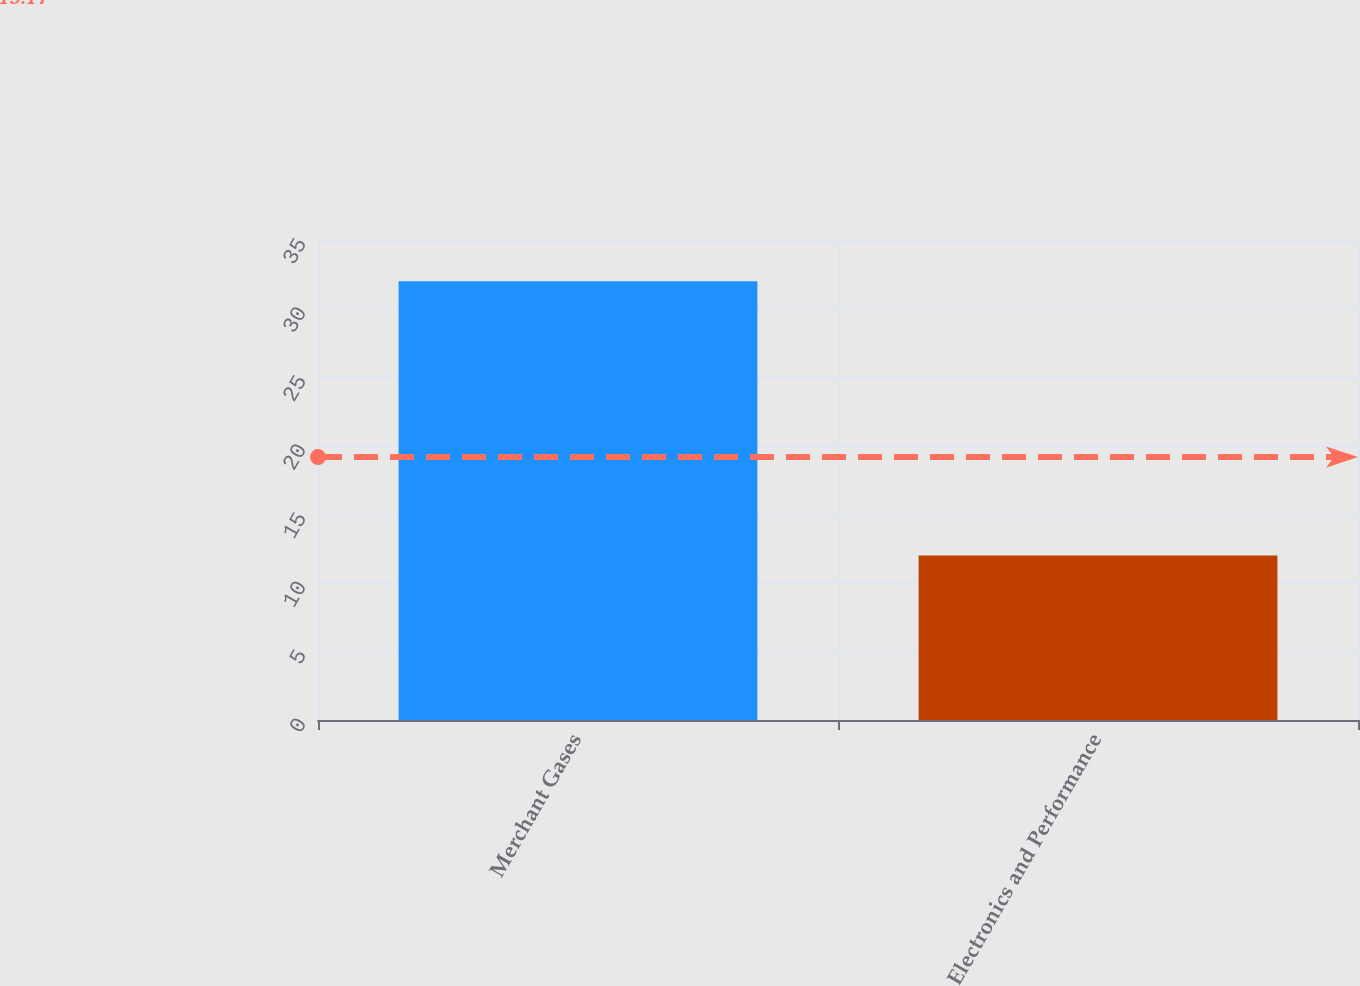<chart> <loc_0><loc_0><loc_500><loc_500><bar_chart><fcel>Merchant Gases<fcel>Electronics and Performance<nl><fcel>32<fcel>12<nl></chart> 